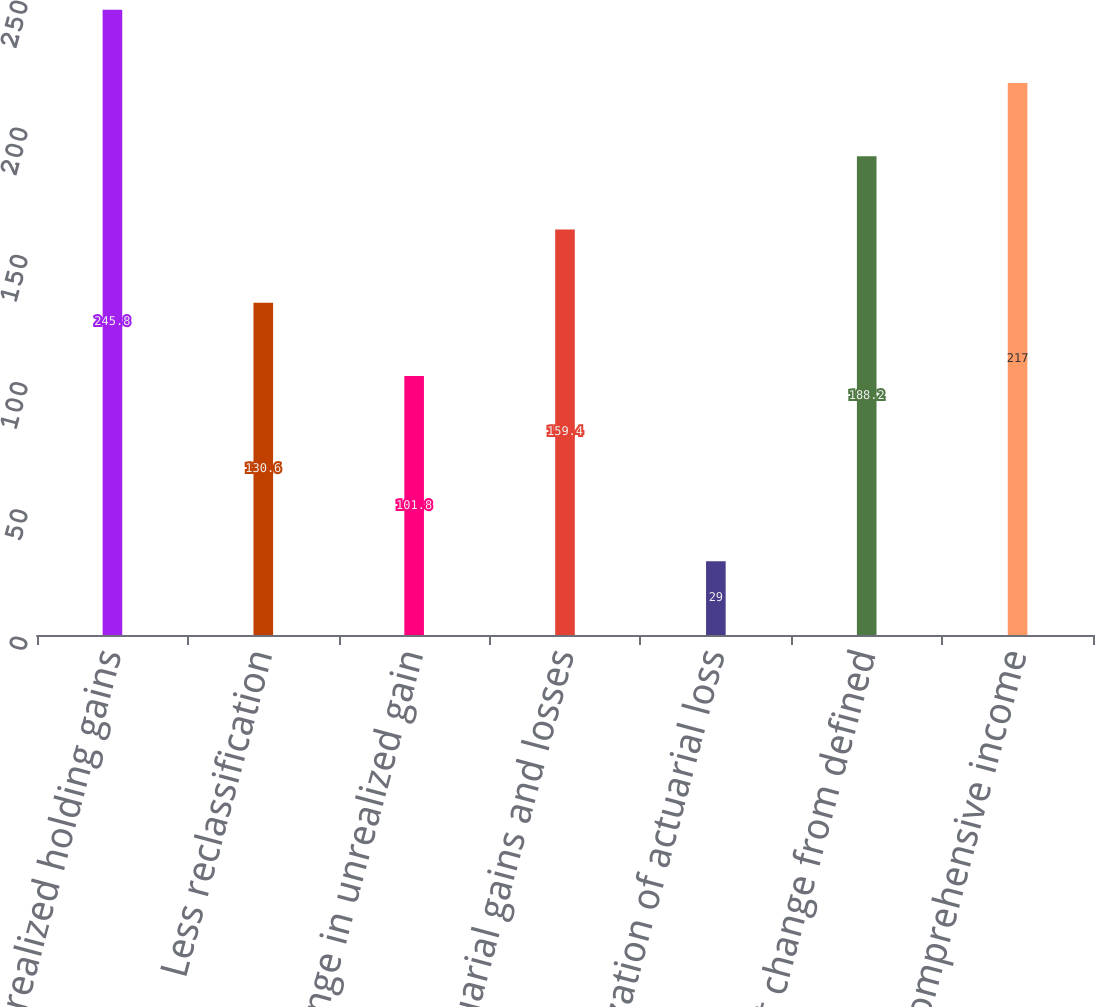Convert chart to OTSL. <chart><loc_0><loc_0><loc_500><loc_500><bar_chart><fcel>Unrealized holding gains<fcel>Less reclassification<fcel>Net change in unrealized gain<fcel>Net actuarial gains and losses<fcel>Amortization of actuarial loss<fcel>Net change from defined<fcel>Other comprehensive income<nl><fcel>245.8<fcel>130.6<fcel>101.8<fcel>159.4<fcel>29<fcel>188.2<fcel>217<nl></chart> 